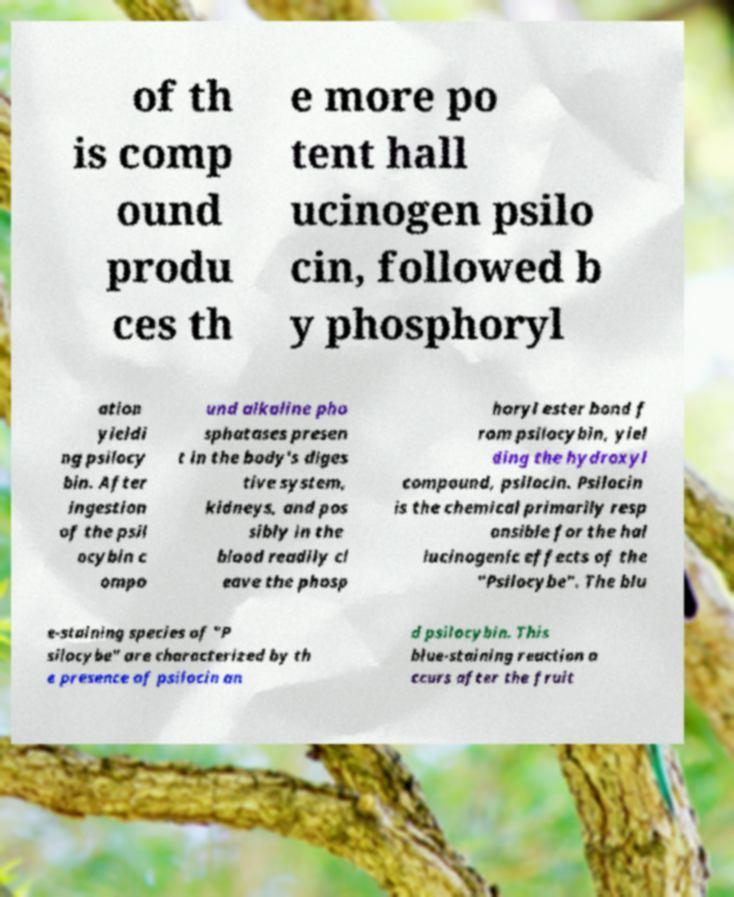Can you accurately transcribe the text from the provided image for me? of th is comp ound produ ces th e more po tent hall ucinogen psilo cin, followed b y phosphoryl ation yieldi ng psilocy bin. After ingestion of the psil ocybin c ompo und alkaline pho sphatases presen t in the body's diges tive system, kidneys, and pos sibly in the blood readily cl eave the phosp horyl ester bond f rom psilocybin, yiel ding the hydroxyl compound, psilocin. Psilocin is the chemical primarily resp onsible for the hal lucinogenic effects of the "Psilocybe". The blu e-staining species of "P silocybe" are characterized by th e presence of psilocin an d psilocybin. This blue-staining reaction o ccurs after the fruit 